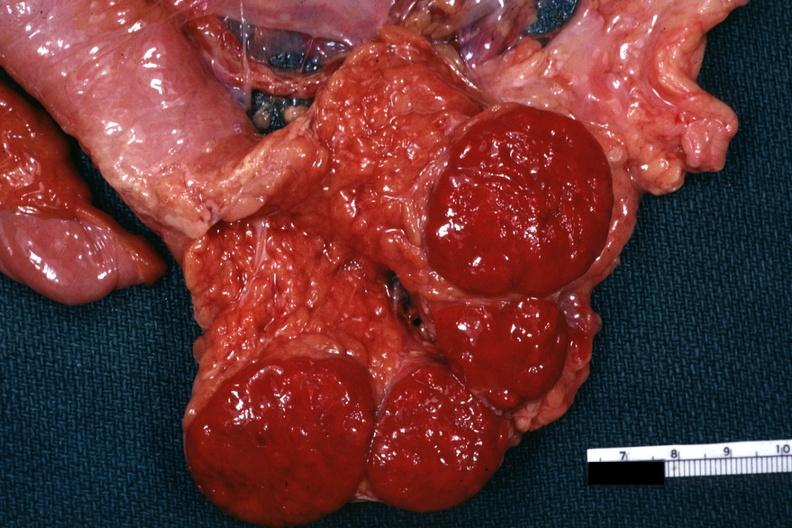what does this image show?
Answer the question using a single word or phrase. Tail of pancreas with spleens 